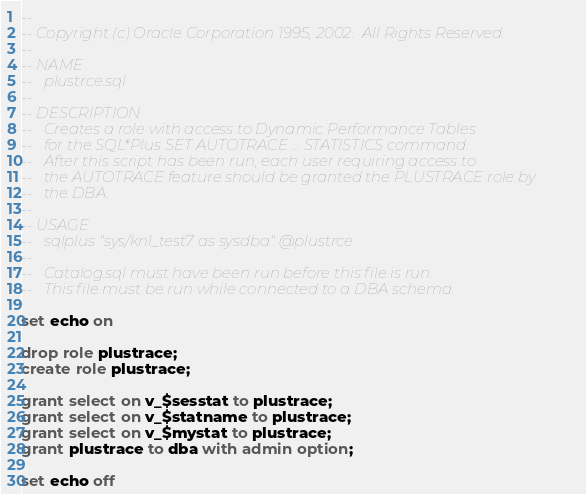<code> <loc_0><loc_0><loc_500><loc_500><_SQL_>--
-- Copyright (c) Oracle Corporation 1995, 2002.  All Rights Reserved.
--
-- NAME
--   plustrce.sql
--
-- DESCRIPTION
--   Creates a role with access to Dynamic Performance Tables
--   for the SQL*Plus SET AUTOTRACE ... STATISTICS command.
--   After this script has been run, each user requiring access to
--   the AUTOTRACE feature should be granted the PLUSTRACE role by
--   the DBA.
--
-- USAGE
--   sqlplus "sys/knl_test7 as sysdba" @plustrce
--
--   Catalog.sql must have been run before this file is run.
--   This file must be run while connected to a DBA schema.

set echo on

drop role plustrace;
create role plustrace;

grant select on v_$sesstat to plustrace;
grant select on v_$statname to plustrace;
grant select on v_$mystat to plustrace;
grant plustrace to dba with admin option;

set echo off
</code> 